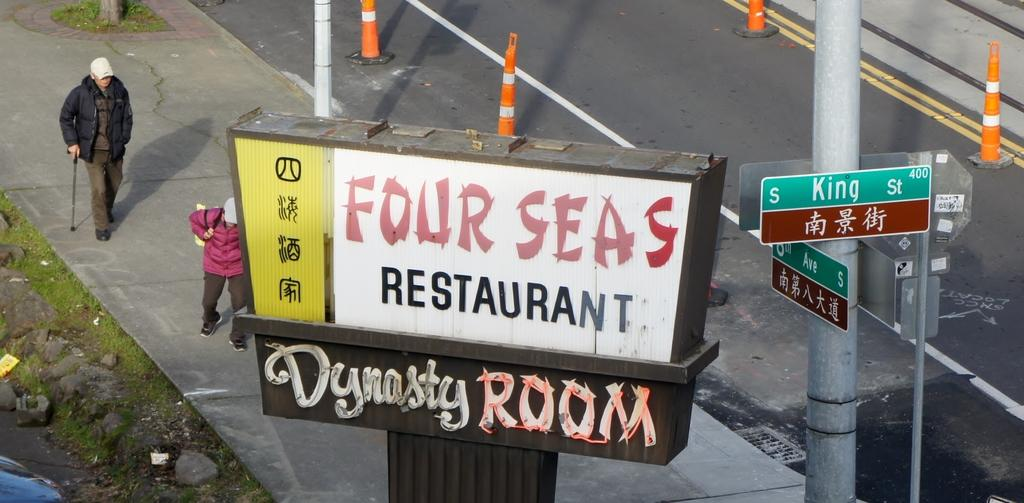<image>
Provide a brief description of the given image. Man walking near a sign that says Four Seas Restaurant. 